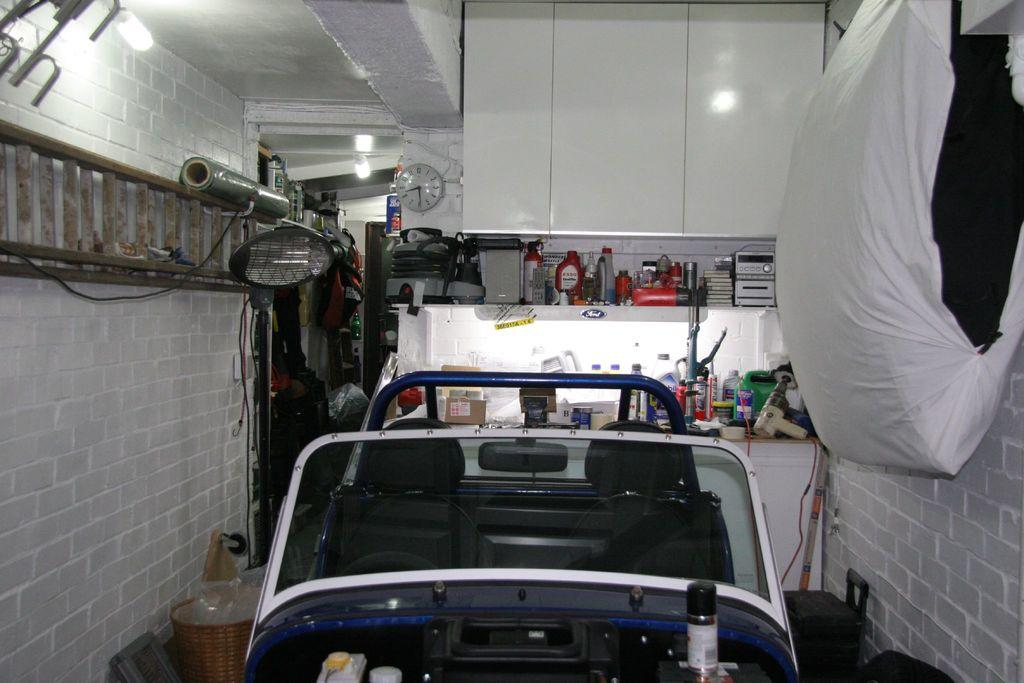What color is the wall in the image? The wall in the image is white. What objects in the image provide illumination? There are lights in the image. What type of furniture is present in the image? There is a cupboard and shelves in the image. What mode of transportation is visible in the image? There is a vehicle in the image. What container is present in the image? There is a basket in the image. What objects are used for waste disposal in the image? There are dustbins in the image. What time-keeping device is present in the image? There is a clock in the image. What type of liquid storage is present in the image? There are bottles in the image. How many children are learning in the image? There are no children or learning activities depicted in the image. What type of authority figure is present in the image? There is no authority figure present in the image. 